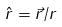Convert formula to latex. <formula><loc_0><loc_0><loc_500><loc_500>\hat { r } = \vec { r } / r</formula> 